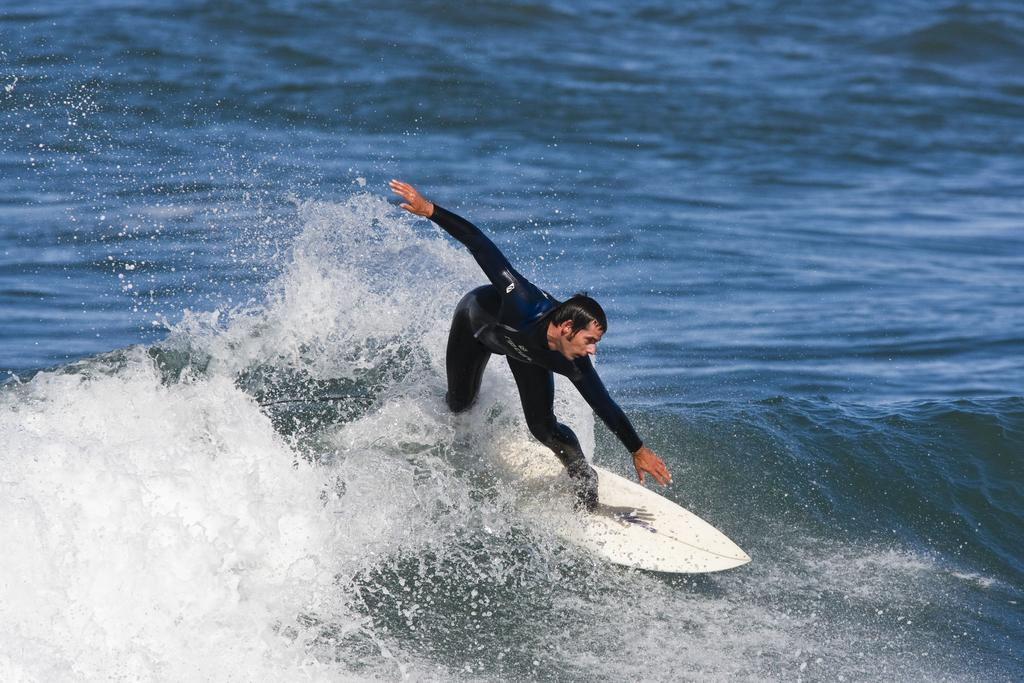What is the person in the image doing? The person is surfing. What tool or equipment is the person using to surf? The person is using a surfboard. Where is the surfboard located in relation to the water? The surfboard is on the water. How many holes can be seen in the surfboard in the image? There are no holes visible in the surfboard in the image. What type of quiver is the person using to hold the surfboard? There is no quiver present in the image; the person is directly on the surfboard. 